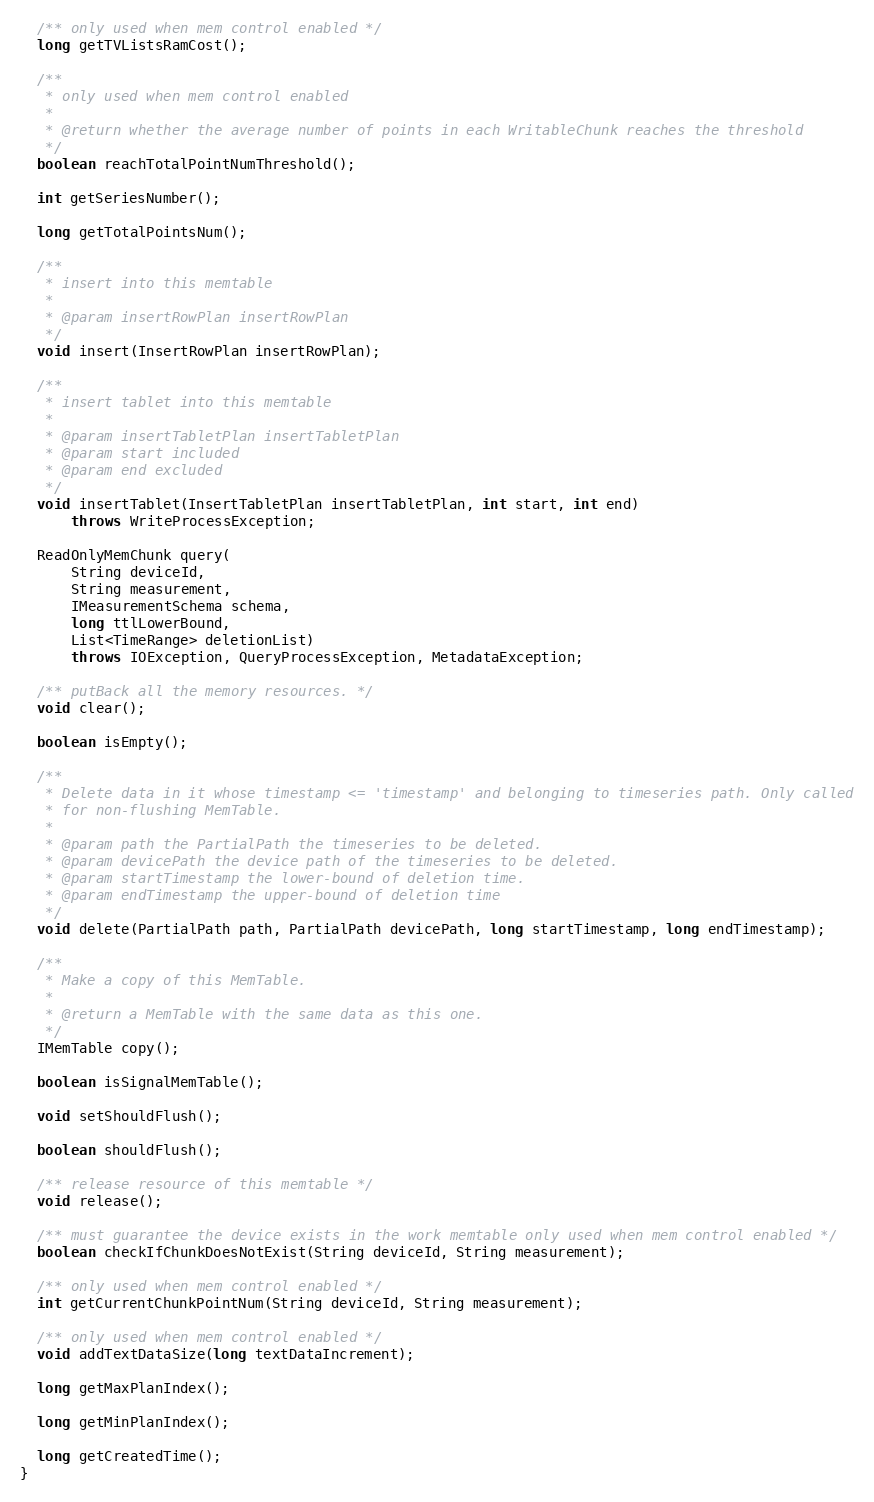Convert code to text. <code><loc_0><loc_0><loc_500><loc_500><_Java_>
  /** only used when mem control enabled */
  long getTVListsRamCost();

  /**
   * only used when mem control enabled
   *
   * @return whether the average number of points in each WritableChunk reaches the threshold
   */
  boolean reachTotalPointNumThreshold();

  int getSeriesNumber();

  long getTotalPointsNum();

  /**
   * insert into this memtable
   *
   * @param insertRowPlan insertRowPlan
   */
  void insert(InsertRowPlan insertRowPlan);

  /**
   * insert tablet into this memtable
   *
   * @param insertTabletPlan insertTabletPlan
   * @param start included
   * @param end excluded
   */
  void insertTablet(InsertTabletPlan insertTabletPlan, int start, int end)
      throws WriteProcessException;

  ReadOnlyMemChunk query(
      String deviceId,
      String measurement,
      IMeasurementSchema schema,
      long ttlLowerBound,
      List<TimeRange> deletionList)
      throws IOException, QueryProcessException, MetadataException;

  /** putBack all the memory resources. */
  void clear();

  boolean isEmpty();

  /**
   * Delete data in it whose timestamp <= 'timestamp' and belonging to timeseries path. Only called
   * for non-flushing MemTable.
   *
   * @param path the PartialPath the timeseries to be deleted.
   * @param devicePath the device path of the timeseries to be deleted.
   * @param startTimestamp the lower-bound of deletion time.
   * @param endTimestamp the upper-bound of deletion time
   */
  void delete(PartialPath path, PartialPath devicePath, long startTimestamp, long endTimestamp);

  /**
   * Make a copy of this MemTable.
   *
   * @return a MemTable with the same data as this one.
   */
  IMemTable copy();

  boolean isSignalMemTable();

  void setShouldFlush();

  boolean shouldFlush();

  /** release resource of this memtable */
  void release();

  /** must guarantee the device exists in the work memtable only used when mem control enabled */
  boolean checkIfChunkDoesNotExist(String deviceId, String measurement);

  /** only used when mem control enabled */
  int getCurrentChunkPointNum(String deviceId, String measurement);

  /** only used when mem control enabled */
  void addTextDataSize(long textDataIncrement);

  long getMaxPlanIndex();

  long getMinPlanIndex();

  long getCreatedTime();
}
</code> 